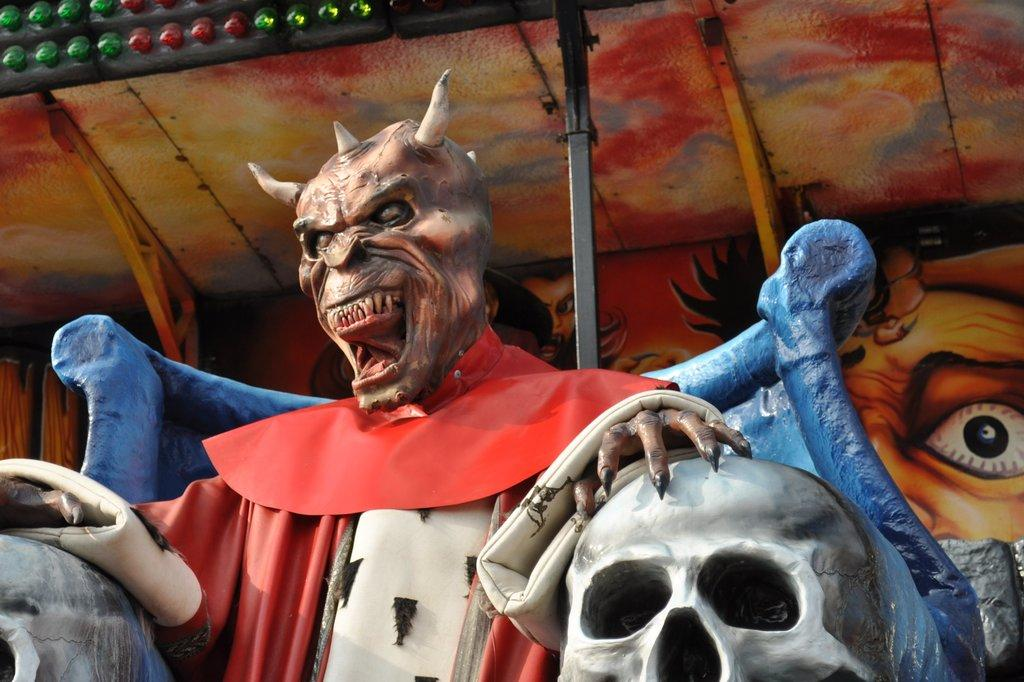What is the main subject in the image? There is a statue in the image. Can you describe the colors of the statue? The statue has brown, red, and white colors. What other object can be seen in the image? There is a skull in the image. How would you describe the background of the image? The background of the image is colorful. How do the giants in the image use the moon for their magic rituals? There are no giants or magic rituals present in the image; it features a statue and a skull with a colorful background. 